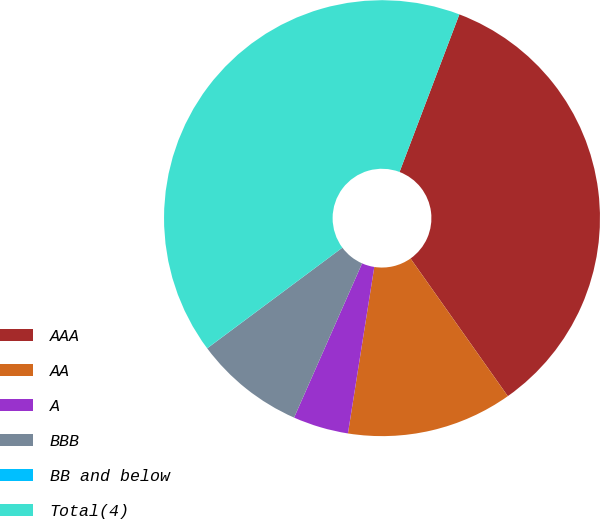Convert chart. <chart><loc_0><loc_0><loc_500><loc_500><pie_chart><fcel>AAA<fcel>AA<fcel>A<fcel>BBB<fcel>BB and below<fcel>Total(4)<nl><fcel>34.43%<fcel>12.29%<fcel>4.11%<fcel>8.2%<fcel>0.01%<fcel>40.95%<nl></chart> 